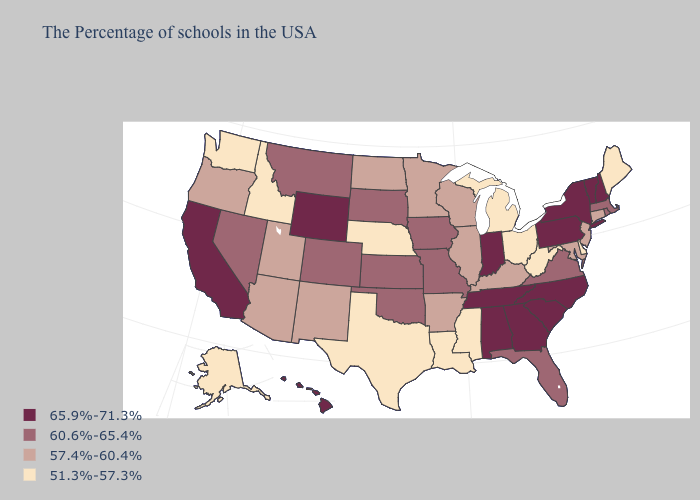Is the legend a continuous bar?
Be succinct. No. Which states have the lowest value in the Northeast?
Keep it brief. Maine. What is the value of Missouri?
Concise answer only. 60.6%-65.4%. Does New Hampshire have a higher value than North Carolina?
Write a very short answer. No. Name the states that have a value in the range 57.4%-60.4%?
Keep it brief. Connecticut, New Jersey, Maryland, Kentucky, Wisconsin, Illinois, Arkansas, Minnesota, North Dakota, New Mexico, Utah, Arizona, Oregon. Does Wyoming have the highest value in the USA?
Short answer required. Yes. Among the states that border Illinois , does Kentucky have the lowest value?
Give a very brief answer. Yes. Does Rhode Island have the highest value in the Northeast?
Concise answer only. No. Name the states that have a value in the range 57.4%-60.4%?
Write a very short answer. Connecticut, New Jersey, Maryland, Kentucky, Wisconsin, Illinois, Arkansas, Minnesota, North Dakota, New Mexico, Utah, Arizona, Oregon. Name the states that have a value in the range 57.4%-60.4%?
Write a very short answer. Connecticut, New Jersey, Maryland, Kentucky, Wisconsin, Illinois, Arkansas, Minnesota, North Dakota, New Mexico, Utah, Arizona, Oregon. Name the states that have a value in the range 57.4%-60.4%?
Give a very brief answer. Connecticut, New Jersey, Maryland, Kentucky, Wisconsin, Illinois, Arkansas, Minnesota, North Dakota, New Mexico, Utah, Arizona, Oregon. Name the states that have a value in the range 60.6%-65.4%?
Be succinct. Massachusetts, Rhode Island, Virginia, Florida, Missouri, Iowa, Kansas, Oklahoma, South Dakota, Colorado, Montana, Nevada. Name the states that have a value in the range 51.3%-57.3%?
Concise answer only. Maine, Delaware, West Virginia, Ohio, Michigan, Mississippi, Louisiana, Nebraska, Texas, Idaho, Washington, Alaska. Name the states that have a value in the range 57.4%-60.4%?
Give a very brief answer. Connecticut, New Jersey, Maryland, Kentucky, Wisconsin, Illinois, Arkansas, Minnesota, North Dakota, New Mexico, Utah, Arizona, Oregon. What is the lowest value in the USA?
Keep it brief. 51.3%-57.3%. 